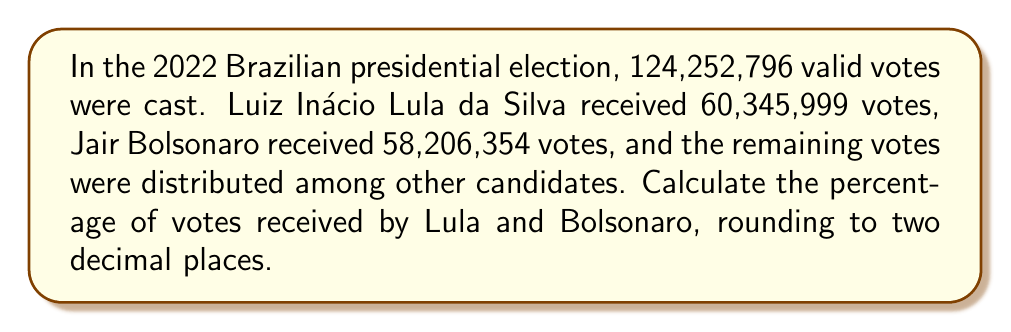Give your solution to this math problem. To calculate the percentage of votes for each candidate, we'll use the formula:

$$ \text{Percentage} = \frac{\text{Candidate's votes}}{\text{Total valid votes}} \times 100\% $$

1. For Lula:
   $$ \text{Lula's percentage} = \frac{60,345,999}{124,252,796} \times 100\% $$
   $$ = 0.4856871... \times 100\% $$
   $$ = 48.57\% \text{ (rounded to two decimal places)} $$

2. For Bolsonaro:
   $$ \text{Bolsonaro's percentage} = \frac{58,206,354}{124,252,796} \times 100\% $$
   $$ = 0.4684470... \times 100\% $$
   $$ = 46.84\% \text{ (rounded to two decimal places)} $$

3. To verify, we can calculate the remaining votes:
   $$ \text{Remaining votes} = 124,252,796 - 60,345,999 - 58,206,354 = 5,700,443 $$
   $$ \text{Remaining percentage} = \frac{5,700,443}{124,252,796} \times 100\% = 4.59\% $$

   $48.57\% + 46.84\% + 4.59\% = 100\%$, confirming our calculations.
Answer: Lula: 48.57%, Bolsonaro: 46.84% 